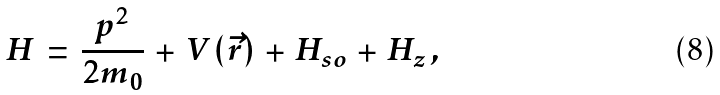Convert formula to latex. <formula><loc_0><loc_0><loc_500><loc_500>H \, = \, \frac { p ^ { 2 } } { 2 m _ { 0 } } \, + \, V ( \vec { r } ) \, + \, H _ { s o } \, + \, H _ { z } \, ,</formula> 